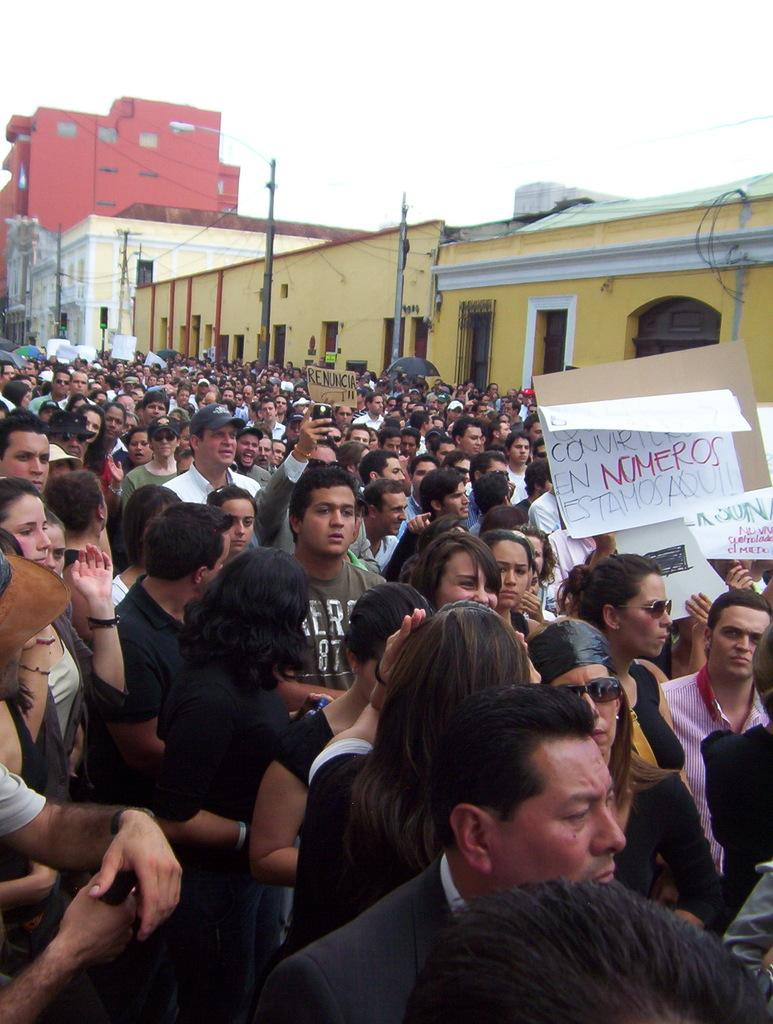How many people are in the image? There is a group of persons in the image. What are some of the persons holding in the image? Some of the persons are holding cardboards with writing on them. What can be seen in the background of the image? There are buildings in the background of the image. Can the persons in the image balance on one foot while holding the cardboards? There is no information about the persons balancing on one foot in the image. 